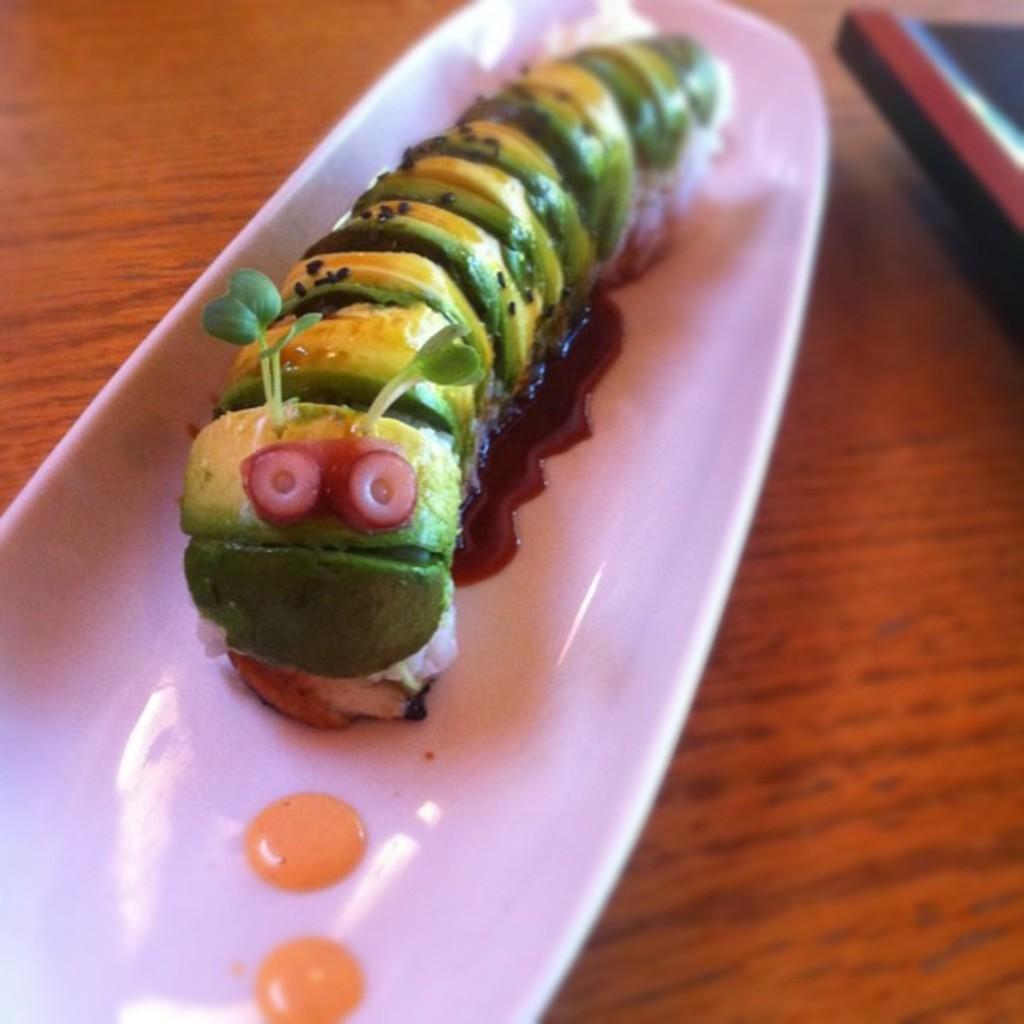In one or two sentences, can you explain what this image depicts? This image consists of a food item kept in a bowl. At the bottom, there is a table. 